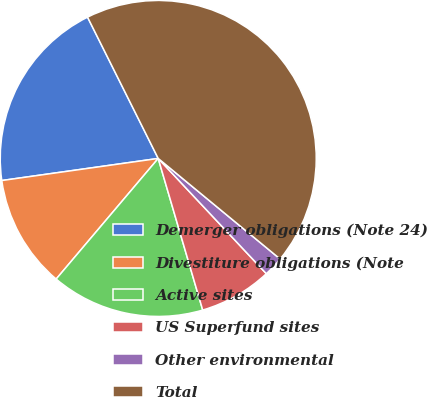Convert chart. <chart><loc_0><loc_0><loc_500><loc_500><pie_chart><fcel>Demerger obligations (Note 24)<fcel>Divestiture obligations (Note<fcel>Active sites<fcel>US Superfund sites<fcel>Other environmental<fcel>Total<nl><fcel>19.85%<fcel>11.59%<fcel>15.72%<fcel>7.45%<fcel>2.03%<fcel>43.36%<nl></chart> 